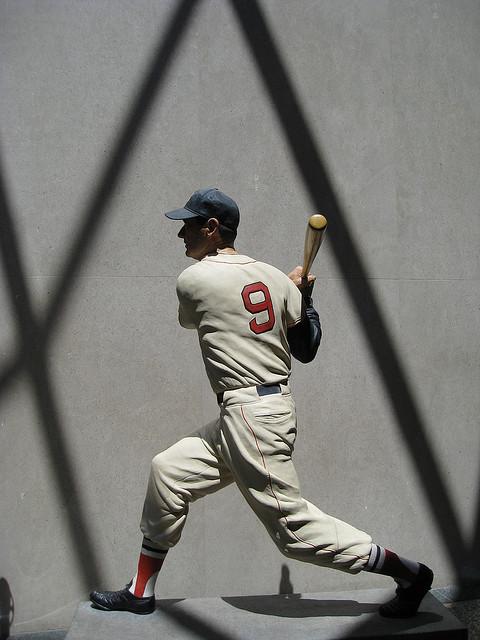How many people are riding?
Short answer required. 0. What number is on the players back?
Concise answer only. 9. Which leg is forward?
Be succinct. Right. What sport is this figure from?
Answer briefly. Baseball. What major sporting event is he a part of?
Keep it brief. Baseball. What number is the batter?
Answer briefly. 9. What is his team number?
Answer briefly. 9. 